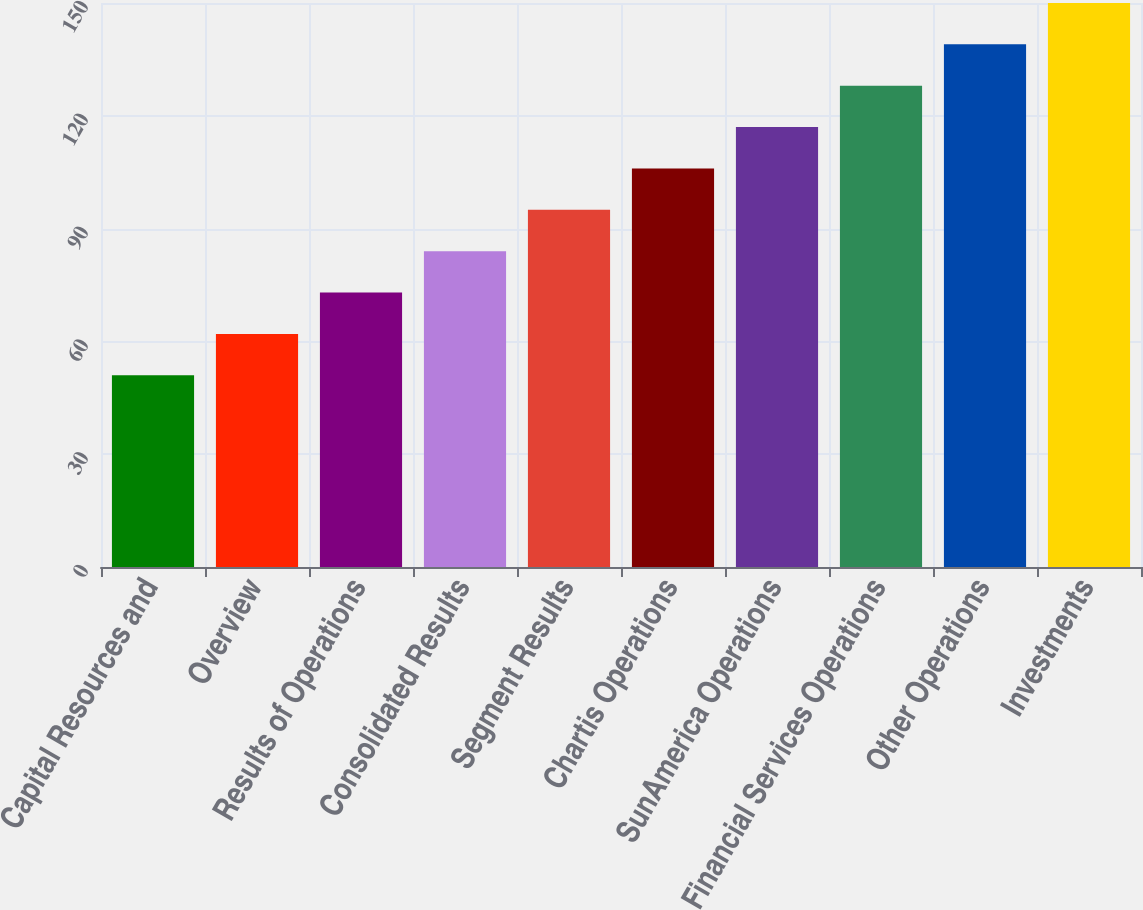<chart> <loc_0><loc_0><loc_500><loc_500><bar_chart><fcel>Capital Resources and<fcel>Overview<fcel>Results of Operations<fcel>Consolidated Results<fcel>Segment Results<fcel>Chartis Operations<fcel>SunAmerica Operations<fcel>Financial Services Operations<fcel>Other Operations<fcel>Investments<nl><fcel>51<fcel>62<fcel>73<fcel>84<fcel>95<fcel>106<fcel>117<fcel>128<fcel>139<fcel>150<nl></chart> 